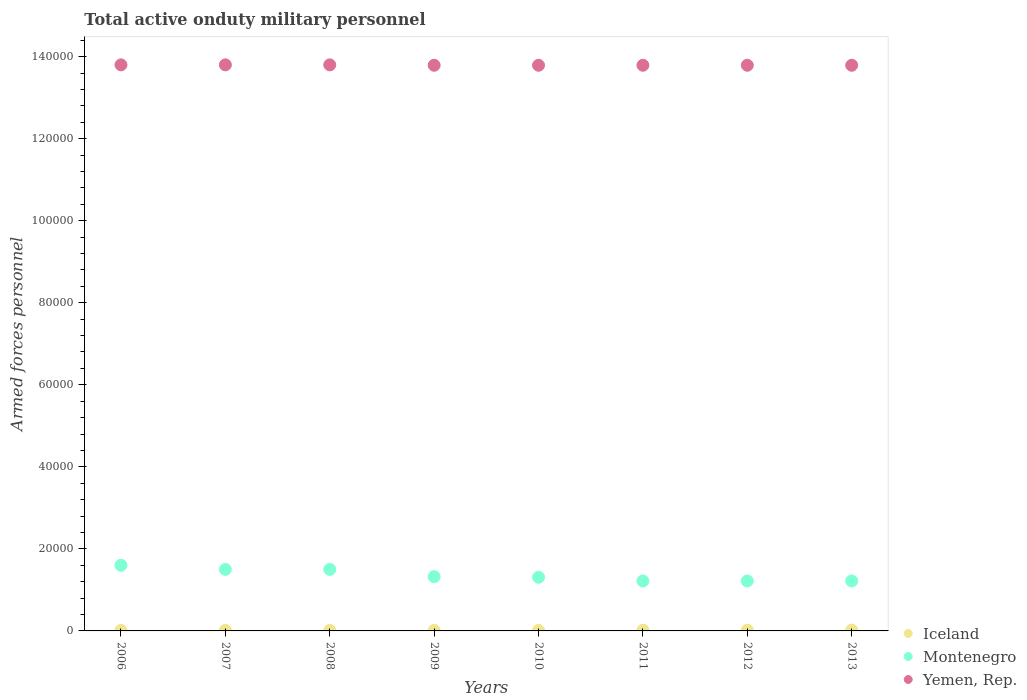Is the number of dotlines equal to the number of legend labels?
Ensure brevity in your answer.  Yes. What is the number of armed forces personnel in Iceland in 2008?
Keep it short and to the point. 130. Across all years, what is the maximum number of armed forces personnel in Montenegro?
Your answer should be very brief. 1.60e+04. Across all years, what is the minimum number of armed forces personnel in Iceland?
Provide a succinct answer. 130. In which year was the number of armed forces personnel in Iceland minimum?
Provide a short and direct response. 2006. What is the total number of armed forces personnel in Iceland in the graph?
Offer a very short reply. 1210. What is the difference between the number of armed forces personnel in Iceland in 2006 and that in 2010?
Provide a short and direct response. 0. What is the difference between the number of armed forces personnel in Yemen, Rep. in 2013 and the number of armed forces personnel in Iceland in 2009?
Provide a short and direct response. 1.38e+05. What is the average number of armed forces personnel in Montenegro per year?
Your answer should be very brief. 1.36e+04. In the year 2011, what is the difference between the number of armed forces personnel in Iceland and number of armed forces personnel in Yemen, Rep.?
Your response must be concise. -1.38e+05. What is the ratio of the number of armed forces personnel in Iceland in 2008 to that in 2011?
Ensure brevity in your answer.  0.72. Is the number of armed forces personnel in Yemen, Rep. in 2007 less than that in 2011?
Keep it short and to the point. No. What is the difference between the highest and the lowest number of armed forces personnel in Iceland?
Make the answer very short. 70. In how many years, is the number of armed forces personnel in Iceland greater than the average number of armed forces personnel in Iceland taken over all years?
Offer a terse response. 3. Does the number of armed forces personnel in Montenegro monotonically increase over the years?
Your answer should be compact. No. Is the number of armed forces personnel in Iceland strictly greater than the number of armed forces personnel in Montenegro over the years?
Make the answer very short. No. How many dotlines are there?
Keep it short and to the point. 3. How many years are there in the graph?
Give a very brief answer. 8. Does the graph contain grids?
Your answer should be compact. No. Where does the legend appear in the graph?
Offer a terse response. Bottom right. How many legend labels are there?
Provide a succinct answer. 3. What is the title of the graph?
Your answer should be compact. Total active onduty military personnel. Does "Russian Federation" appear as one of the legend labels in the graph?
Give a very brief answer. No. What is the label or title of the Y-axis?
Provide a short and direct response. Armed forces personnel. What is the Armed forces personnel of Iceland in 2006?
Offer a terse response. 130. What is the Armed forces personnel of Montenegro in 2006?
Ensure brevity in your answer.  1.60e+04. What is the Armed forces personnel in Yemen, Rep. in 2006?
Provide a short and direct response. 1.38e+05. What is the Armed forces personnel in Iceland in 2007?
Your answer should be compact. 130. What is the Armed forces personnel of Montenegro in 2007?
Your response must be concise. 1.50e+04. What is the Armed forces personnel in Yemen, Rep. in 2007?
Offer a terse response. 1.38e+05. What is the Armed forces personnel of Iceland in 2008?
Your answer should be compact. 130. What is the Armed forces personnel of Montenegro in 2008?
Ensure brevity in your answer.  1.50e+04. What is the Armed forces personnel in Yemen, Rep. in 2008?
Your answer should be very brief. 1.38e+05. What is the Armed forces personnel of Iceland in 2009?
Provide a short and direct response. 130. What is the Armed forces personnel in Montenegro in 2009?
Give a very brief answer. 1.32e+04. What is the Armed forces personnel in Yemen, Rep. in 2009?
Offer a very short reply. 1.38e+05. What is the Armed forces personnel of Iceland in 2010?
Provide a short and direct response. 130. What is the Armed forces personnel of Montenegro in 2010?
Offer a terse response. 1.31e+04. What is the Armed forces personnel of Yemen, Rep. in 2010?
Keep it short and to the point. 1.38e+05. What is the Armed forces personnel in Iceland in 2011?
Your answer should be compact. 180. What is the Armed forces personnel of Montenegro in 2011?
Offer a very short reply. 1.22e+04. What is the Armed forces personnel in Yemen, Rep. in 2011?
Your answer should be very brief. 1.38e+05. What is the Armed forces personnel of Iceland in 2012?
Ensure brevity in your answer.  180. What is the Armed forces personnel in Montenegro in 2012?
Your answer should be compact. 1.22e+04. What is the Armed forces personnel of Yemen, Rep. in 2012?
Provide a succinct answer. 1.38e+05. What is the Armed forces personnel in Montenegro in 2013?
Your answer should be very brief. 1.22e+04. What is the Armed forces personnel of Yemen, Rep. in 2013?
Offer a terse response. 1.38e+05. Across all years, what is the maximum Armed forces personnel of Montenegro?
Provide a succinct answer. 1.60e+04. Across all years, what is the maximum Armed forces personnel of Yemen, Rep.?
Ensure brevity in your answer.  1.38e+05. Across all years, what is the minimum Armed forces personnel in Iceland?
Your response must be concise. 130. Across all years, what is the minimum Armed forces personnel in Montenegro?
Offer a very short reply. 1.22e+04. Across all years, what is the minimum Armed forces personnel of Yemen, Rep.?
Provide a succinct answer. 1.38e+05. What is the total Armed forces personnel in Iceland in the graph?
Your answer should be very brief. 1210. What is the total Armed forces personnel of Montenegro in the graph?
Provide a succinct answer. 1.09e+05. What is the total Armed forces personnel of Yemen, Rep. in the graph?
Give a very brief answer. 1.10e+06. What is the difference between the Armed forces personnel of Iceland in 2006 and that in 2007?
Offer a terse response. 0. What is the difference between the Armed forces personnel of Iceland in 2006 and that in 2008?
Provide a short and direct response. 0. What is the difference between the Armed forces personnel in Montenegro in 2006 and that in 2008?
Offer a very short reply. 1000. What is the difference between the Armed forces personnel in Montenegro in 2006 and that in 2009?
Provide a short and direct response. 2773. What is the difference between the Armed forces personnel in Montenegro in 2006 and that in 2010?
Keep it short and to the point. 2916. What is the difference between the Armed forces personnel in Yemen, Rep. in 2006 and that in 2010?
Your answer should be compact. 100. What is the difference between the Armed forces personnel of Iceland in 2006 and that in 2011?
Provide a short and direct response. -50. What is the difference between the Armed forces personnel in Montenegro in 2006 and that in 2011?
Make the answer very short. 3820. What is the difference between the Armed forces personnel of Montenegro in 2006 and that in 2012?
Offer a very short reply. 3820. What is the difference between the Armed forces personnel in Iceland in 2006 and that in 2013?
Your answer should be very brief. -70. What is the difference between the Armed forces personnel of Montenegro in 2006 and that in 2013?
Your answer should be very brief. 3820. What is the difference between the Armed forces personnel of Iceland in 2007 and that in 2008?
Offer a very short reply. 0. What is the difference between the Armed forces personnel in Yemen, Rep. in 2007 and that in 2008?
Your answer should be compact. 0. What is the difference between the Armed forces personnel of Montenegro in 2007 and that in 2009?
Keep it short and to the point. 1773. What is the difference between the Armed forces personnel of Yemen, Rep. in 2007 and that in 2009?
Provide a short and direct response. 100. What is the difference between the Armed forces personnel of Montenegro in 2007 and that in 2010?
Offer a very short reply. 1916. What is the difference between the Armed forces personnel in Montenegro in 2007 and that in 2011?
Provide a succinct answer. 2820. What is the difference between the Armed forces personnel of Montenegro in 2007 and that in 2012?
Your answer should be compact. 2820. What is the difference between the Armed forces personnel of Iceland in 2007 and that in 2013?
Your response must be concise. -70. What is the difference between the Armed forces personnel in Montenegro in 2007 and that in 2013?
Ensure brevity in your answer.  2820. What is the difference between the Armed forces personnel of Iceland in 2008 and that in 2009?
Provide a short and direct response. 0. What is the difference between the Armed forces personnel of Montenegro in 2008 and that in 2009?
Offer a terse response. 1773. What is the difference between the Armed forces personnel in Iceland in 2008 and that in 2010?
Your response must be concise. 0. What is the difference between the Armed forces personnel in Montenegro in 2008 and that in 2010?
Your answer should be compact. 1916. What is the difference between the Armed forces personnel in Montenegro in 2008 and that in 2011?
Provide a short and direct response. 2820. What is the difference between the Armed forces personnel in Yemen, Rep. in 2008 and that in 2011?
Your response must be concise. 100. What is the difference between the Armed forces personnel of Montenegro in 2008 and that in 2012?
Offer a terse response. 2820. What is the difference between the Armed forces personnel of Yemen, Rep. in 2008 and that in 2012?
Your answer should be very brief. 100. What is the difference between the Armed forces personnel in Iceland in 2008 and that in 2013?
Provide a short and direct response. -70. What is the difference between the Armed forces personnel of Montenegro in 2008 and that in 2013?
Give a very brief answer. 2820. What is the difference between the Armed forces personnel in Yemen, Rep. in 2008 and that in 2013?
Ensure brevity in your answer.  100. What is the difference between the Armed forces personnel of Iceland in 2009 and that in 2010?
Make the answer very short. 0. What is the difference between the Armed forces personnel of Montenegro in 2009 and that in 2010?
Give a very brief answer. 143. What is the difference between the Armed forces personnel in Montenegro in 2009 and that in 2011?
Provide a succinct answer. 1047. What is the difference between the Armed forces personnel in Yemen, Rep. in 2009 and that in 2011?
Give a very brief answer. 0. What is the difference between the Armed forces personnel in Montenegro in 2009 and that in 2012?
Your answer should be compact. 1047. What is the difference between the Armed forces personnel in Yemen, Rep. in 2009 and that in 2012?
Make the answer very short. 0. What is the difference between the Armed forces personnel in Iceland in 2009 and that in 2013?
Your answer should be compact. -70. What is the difference between the Armed forces personnel of Montenegro in 2009 and that in 2013?
Ensure brevity in your answer.  1047. What is the difference between the Armed forces personnel of Montenegro in 2010 and that in 2011?
Your response must be concise. 904. What is the difference between the Armed forces personnel in Iceland in 2010 and that in 2012?
Keep it short and to the point. -50. What is the difference between the Armed forces personnel of Montenegro in 2010 and that in 2012?
Make the answer very short. 904. What is the difference between the Armed forces personnel of Iceland in 2010 and that in 2013?
Offer a very short reply. -70. What is the difference between the Armed forces personnel of Montenegro in 2010 and that in 2013?
Provide a short and direct response. 904. What is the difference between the Armed forces personnel in Yemen, Rep. in 2010 and that in 2013?
Provide a short and direct response. 0. What is the difference between the Armed forces personnel in Iceland in 2011 and that in 2012?
Offer a terse response. 0. What is the difference between the Armed forces personnel of Yemen, Rep. in 2011 and that in 2012?
Ensure brevity in your answer.  0. What is the difference between the Armed forces personnel of Iceland in 2012 and that in 2013?
Your answer should be compact. -20. What is the difference between the Armed forces personnel in Montenegro in 2012 and that in 2013?
Your response must be concise. 0. What is the difference between the Armed forces personnel in Iceland in 2006 and the Armed forces personnel in Montenegro in 2007?
Provide a short and direct response. -1.49e+04. What is the difference between the Armed forces personnel of Iceland in 2006 and the Armed forces personnel of Yemen, Rep. in 2007?
Your answer should be compact. -1.38e+05. What is the difference between the Armed forces personnel of Montenegro in 2006 and the Armed forces personnel of Yemen, Rep. in 2007?
Offer a terse response. -1.22e+05. What is the difference between the Armed forces personnel of Iceland in 2006 and the Armed forces personnel of Montenegro in 2008?
Make the answer very short. -1.49e+04. What is the difference between the Armed forces personnel of Iceland in 2006 and the Armed forces personnel of Yemen, Rep. in 2008?
Your response must be concise. -1.38e+05. What is the difference between the Armed forces personnel in Montenegro in 2006 and the Armed forces personnel in Yemen, Rep. in 2008?
Make the answer very short. -1.22e+05. What is the difference between the Armed forces personnel in Iceland in 2006 and the Armed forces personnel in Montenegro in 2009?
Ensure brevity in your answer.  -1.31e+04. What is the difference between the Armed forces personnel in Iceland in 2006 and the Armed forces personnel in Yemen, Rep. in 2009?
Keep it short and to the point. -1.38e+05. What is the difference between the Armed forces personnel in Montenegro in 2006 and the Armed forces personnel in Yemen, Rep. in 2009?
Your response must be concise. -1.22e+05. What is the difference between the Armed forces personnel in Iceland in 2006 and the Armed forces personnel in Montenegro in 2010?
Offer a terse response. -1.30e+04. What is the difference between the Armed forces personnel in Iceland in 2006 and the Armed forces personnel in Yemen, Rep. in 2010?
Offer a terse response. -1.38e+05. What is the difference between the Armed forces personnel of Montenegro in 2006 and the Armed forces personnel of Yemen, Rep. in 2010?
Give a very brief answer. -1.22e+05. What is the difference between the Armed forces personnel in Iceland in 2006 and the Armed forces personnel in Montenegro in 2011?
Ensure brevity in your answer.  -1.20e+04. What is the difference between the Armed forces personnel in Iceland in 2006 and the Armed forces personnel in Yemen, Rep. in 2011?
Offer a very short reply. -1.38e+05. What is the difference between the Armed forces personnel of Montenegro in 2006 and the Armed forces personnel of Yemen, Rep. in 2011?
Offer a very short reply. -1.22e+05. What is the difference between the Armed forces personnel of Iceland in 2006 and the Armed forces personnel of Montenegro in 2012?
Make the answer very short. -1.20e+04. What is the difference between the Armed forces personnel in Iceland in 2006 and the Armed forces personnel in Yemen, Rep. in 2012?
Provide a short and direct response. -1.38e+05. What is the difference between the Armed forces personnel of Montenegro in 2006 and the Armed forces personnel of Yemen, Rep. in 2012?
Offer a terse response. -1.22e+05. What is the difference between the Armed forces personnel of Iceland in 2006 and the Armed forces personnel of Montenegro in 2013?
Keep it short and to the point. -1.20e+04. What is the difference between the Armed forces personnel in Iceland in 2006 and the Armed forces personnel in Yemen, Rep. in 2013?
Keep it short and to the point. -1.38e+05. What is the difference between the Armed forces personnel of Montenegro in 2006 and the Armed forces personnel of Yemen, Rep. in 2013?
Provide a succinct answer. -1.22e+05. What is the difference between the Armed forces personnel in Iceland in 2007 and the Armed forces personnel in Montenegro in 2008?
Make the answer very short. -1.49e+04. What is the difference between the Armed forces personnel of Iceland in 2007 and the Armed forces personnel of Yemen, Rep. in 2008?
Your answer should be very brief. -1.38e+05. What is the difference between the Armed forces personnel of Montenegro in 2007 and the Armed forces personnel of Yemen, Rep. in 2008?
Offer a terse response. -1.23e+05. What is the difference between the Armed forces personnel of Iceland in 2007 and the Armed forces personnel of Montenegro in 2009?
Make the answer very short. -1.31e+04. What is the difference between the Armed forces personnel of Iceland in 2007 and the Armed forces personnel of Yemen, Rep. in 2009?
Provide a short and direct response. -1.38e+05. What is the difference between the Armed forces personnel of Montenegro in 2007 and the Armed forces personnel of Yemen, Rep. in 2009?
Provide a short and direct response. -1.23e+05. What is the difference between the Armed forces personnel of Iceland in 2007 and the Armed forces personnel of Montenegro in 2010?
Your answer should be compact. -1.30e+04. What is the difference between the Armed forces personnel in Iceland in 2007 and the Armed forces personnel in Yemen, Rep. in 2010?
Provide a short and direct response. -1.38e+05. What is the difference between the Armed forces personnel of Montenegro in 2007 and the Armed forces personnel of Yemen, Rep. in 2010?
Offer a terse response. -1.23e+05. What is the difference between the Armed forces personnel in Iceland in 2007 and the Armed forces personnel in Montenegro in 2011?
Your answer should be compact. -1.20e+04. What is the difference between the Armed forces personnel in Iceland in 2007 and the Armed forces personnel in Yemen, Rep. in 2011?
Offer a very short reply. -1.38e+05. What is the difference between the Armed forces personnel of Montenegro in 2007 and the Armed forces personnel of Yemen, Rep. in 2011?
Offer a terse response. -1.23e+05. What is the difference between the Armed forces personnel of Iceland in 2007 and the Armed forces personnel of Montenegro in 2012?
Provide a short and direct response. -1.20e+04. What is the difference between the Armed forces personnel of Iceland in 2007 and the Armed forces personnel of Yemen, Rep. in 2012?
Your answer should be compact. -1.38e+05. What is the difference between the Armed forces personnel in Montenegro in 2007 and the Armed forces personnel in Yemen, Rep. in 2012?
Make the answer very short. -1.23e+05. What is the difference between the Armed forces personnel in Iceland in 2007 and the Armed forces personnel in Montenegro in 2013?
Ensure brevity in your answer.  -1.20e+04. What is the difference between the Armed forces personnel of Iceland in 2007 and the Armed forces personnel of Yemen, Rep. in 2013?
Ensure brevity in your answer.  -1.38e+05. What is the difference between the Armed forces personnel of Montenegro in 2007 and the Armed forces personnel of Yemen, Rep. in 2013?
Keep it short and to the point. -1.23e+05. What is the difference between the Armed forces personnel of Iceland in 2008 and the Armed forces personnel of Montenegro in 2009?
Give a very brief answer. -1.31e+04. What is the difference between the Armed forces personnel of Iceland in 2008 and the Armed forces personnel of Yemen, Rep. in 2009?
Provide a short and direct response. -1.38e+05. What is the difference between the Armed forces personnel of Montenegro in 2008 and the Armed forces personnel of Yemen, Rep. in 2009?
Make the answer very short. -1.23e+05. What is the difference between the Armed forces personnel of Iceland in 2008 and the Armed forces personnel of Montenegro in 2010?
Your response must be concise. -1.30e+04. What is the difference between the Armed forces personnel of Iceland in 2008 and the Armed forces personnel of Yemen, Rep. in 2010?
Keep it short and to the point. -1.38e+05. What is the difference between the Armed forces personnel of Montenegro in 2008 and the Armed forces personnel of Yemen, Rep. in 2010?
Provide a short and direct response. -1.23e+05. What is the difference between the Armed forces personnel in Iceland in 2008 and the Armed forces personnel in Montenegro in 2011?
Your answer should be very brief. -1.20e+04. What is the difference between the Armed forces personnel in Iceland in 2008 and the Armed forces personnel in Yemen, Rep. in 2011?
Provide a short and direct response. -1.38e+05. What is the difference between the Armed forces personnel in Montenegro in 2008 and the Armed forces personnel in Yemen, Rep. in 2011?
Provide a short and direct response. -1.23e+05. What is the difference between the Armed forces personnel in Iceland in 2008 and the Armed forces personnel in Montenegro in 2012?
Give a very brief answer. -1.20e+04. What is the difference between the Armed forces personnel in Iceland in 2008 and the Armed forces personnel in Yemen, Rep. in 2012?
Give a very brief answer. -1.38e+05. What is the difference between the Armed forces personnel in Montenegro in 2008 and the Armed forces personnel in Yemen, Rep. in 2012?
Provide a short and direct response. -1.23e+05. What is the difference between the Armed forces personnel in Iceland in 2008 and the Armed forces personnel in Montenegro in 2013?
Your answer should be compact. -1.20e+04. What is the difference between the Armed forces personnel of Iceland in 2008 and the Armed forces personnel of Yemen, Rep. in 2013?
Your answer should be very brief. -1.38e+05. What is the difference between the Armed forces personnel of Montenegro in 2008 and the Armed forces personnel of Yemen, Rep. in 2013?
Keep it short and to the point. -1.23e+05. What is the difference between the Armed forces personnel of Iceland in 2009 and the Armed forces personnel of Montenegro in 2010?
Provide a short and direct response. -1.30e+04. What is the difference between the Armed forces personnel in Iceland in 2009 and the Armed forces personnel in Yemen, Rep. in 2010?
Your response must be concise. -1.38e+05. What is the difference between the Armed forces personnel in Montenegro in 2009 and the Armed forces personnel in Yemen, Rep. in 2010?
Your response must be concise. -1.25e+05. What is the difference between the Armed forces personnel of Iceland in 2009 and the Armed forces personnel of Montenegro in 2011?
Your answer should be very brief. -1.20e+04. What is the difference between the Armed forces personnel of Iceland in 2009 and the Armed forces personnel of Yemen, Rep. in 2011?
Keep it short and to the point. -1.38e+05. What is the difference between the Armed forces personnel of Montenegro in 2009 and the Armed forces personnel of Yemen, Rep. in 2011?
Your response must be concise. -1.25e+05. What is the difference between the Armed forces personnel of Iceland in 2009 and the Armed forces personnel of Montenegro in 2012?
Provide a short and direct response. -1.20e+04. What is the difference between the Armed forces personnel of Iceland in 2009 and the Armed forces personnel of Yemen, Rep. in 2012?
Offer a terse response. -1.38e+05. What is the difference between the Armed forces personnel of Montenegro in 2009 and the Armed forces personnel of Yemen, Rep. in 2012?
Ensure brevity in your answer.  -1.25e+05. What is the difference between the Armed forces personnel of Iceland in 2009 and the Armed forces personnel of Montenegro in 2013?
Offer a terse response. -1.20e+04. What is the difference between the Armed forces personnel in Iceland in 2009 and the Armed forces personnel in Yemen, Rep. in 2013?
Offer a terse response. -1.38e+05. What is the difference between the Armed forces personnel of Montenegro in 2009 and the Armed forces personnel of Yemen, Rep. in 2013?
Your answer should be compact. -1.25e+05. What is the difference between the Armed forces personnel of Iceland in 2010 and the Armed forces personnel of Montenegro in 2011?
Ensure brevity in your answer.  -1.20e+04. What is the difference between the Armed forces personnel in Iceland in 2010 and the Armed forces personnel in Yemen, Rep. in 2011?
Your answer should be compact. -1.38e+05. What is the difference between the Armed forces personnel of Montenegro in 2010 and the Armed forces personnel of Yemen, Rep. in 2011?
Offer a terse response. -1.25e+05. What is the difference between the Armed forces personnel of Iceland in 2010 and the Armed forces personnel of Montenegro in 2012?
Give a very brief answer. -1.20e+04. What is the difference between the Armed forces personnel of Iceland in 2010 and the Armed forces personnel of Yemen, Rep. in 2012?
Provide a short and direct response. -1.38e+05. What is the difference between the Armed forces personnel of Montenegro in 2010 and the Armed forces personnel of Yemen, Rep. in 2012?
Provide a succinct answer. -1.25e+05. What is the difference between the Armed forces personnel of Iceland in 2010 and the Armed forces personnel of Montenegro in 2013?
Provide a short and direct response. -1.20e+04. What is the difference between the Armed forces personnel of Iceland in 2010 and the Armed forces personnel of Yemen, Rep. in 2013?
Provide a short and direct response. -1.38e+05. What is the difference between the Armed forces personnel in Montenegro in 2010 and the Armed forces personnel in Yemen, Rep. in 2013?
Your answer should be compact. -1.25e+05. What is the difference between the Armed forces personnel in Iceland in 2011 and the Armed forces personnel in Montenegro in 2012?
Offer a very short reply. -1.20e+04. What is the difference between the Armed forces personnel in Iceland in 2011 and the Armed forces personnel in Yemen, Rep. in 2012?
Your response must be concise. -1.38e+05. What is the difference between the Armed forces personnel in Montenegro in 2011 and the Armed forces personnel in Yemen, Rep. in 2012?
Provide a short and direct response. -1.26e+05. What is the difference between the Armed forces personnel in Iceland in 2011 and the Armed forces personnel in Montenegro in 2013?
Keep it short and to the point. -1.20e+04. What is the difference between the Armed forces personnel of Iceland in 2011 and the Armed forces personnel of Yemen, Rep. in 2013?
Provide a succinct answer. -1.38e+05. What is the difference between the Armed forces personnel of Montenegro in 2011 and the Armed forces personnel of Yemen, Rep. in 2013?
Give a very brief answer. -1.26e+05. What is the difference between the Armed forces personnel of Iceland in 2012 and the Armed forces personnel of Montenegro in 2013?
Your answer should be very brief. -1.20e+04. What is the difference between the Armed forces personnel in Iceland in 2012 and the Armed forces personnel in Yemen, Rep. in 2013?
Ensure brevity in your answer.  -1.38e+05. What is the difference between the Armed forces personnel of Montenegro in 2012 and the Armed forces personnel of Yemen, Rep. in 2013?
Offer a terse response. -1.26e+05. What is the average Armed forces personnel in Iceland per year?
Your answer should be compact. 151.25. What is the average Armed forces personnel of Montenegro per year?
Your answer should be compact. 1.36e+04. What is the average Armed forces personnel of Yemen, Rep. per year?
Your response must be concise. 1.38e+05. In the year 2006, what is the difference between the Armed forces personnel of Iceland and Armed forces personnel of Montenegro?
Your response must be concise. -1.59e+04. In the year 2006, what is the difference between the Armed forces personnel in Iceland and Armed forces personnel in Yemen, Rep.?
Your response must be concise. -1.38e+05. In the year 2006, what is the difference between the Armed forces personnel of Montenegro and Armed forces personnel of Yemen, Rep.?
Give a very brief answer. -1.22e+05. In the year 2007, what is the difference between the Armed forces personnel in Iceland and Armed forces personnel in Montenegro?
Offer a terse response. -1.49e+04. In the year 2007, what is the difference between the Armed forces personnel of Iceland and Armed forces personnel of Yemen, Rep.?
Offer a terse response. -1.38e+05. In the year 2007, what is the difference between the Armed forces personnel in Montenegro and Armed forces personnel in Yemen, Rep.?
Give a very brief answer. -1.23e+05. In the year 2008, what is the difference between the Armed forces personnel of Iceland and Armed forces personnel of Montenegro?
Provide a succinct answer. -1.49e+04. In the year 2008, what is the difference between the Armed forces personnel of Iceland and Armed forces personnel of Yemen, Rep.?
Ensure brevity in your answer.  -1.38e+05. In the year 2008, what is the difference between the Armed forces personnel of Montenegro and Armed forces personnel of Yemen, Rep.?
Your response must be concise. -1.23e+05. In the year 2009, what is the difference between the Armed forces personnel of Iceland and Armed forces personnel of Montenegro?
Your answer should be compact. -1.31e+04. In the year 2009, what is the difference between the Armed forces personnel of Iceland and Armed forces personnel of Yemen, Rep.?
Keep it short and to the point. -1.38e+05. In the year 2009, what is the difference between the Armed forces personnel in Montenegro and Armed forces personnel in Yemen, Rep.?
Your answer should be very brief. -1.25e+05. In the year 2010, what is the difference between the Armed forces personnel of Iceland and Armed forces personnel of Montenegro?
Ensure brevity in your answer.  -1.30e+04. In the year 2010, what is the difference between the Armed forces personnel in Iceland and Armed forces personnel in Yemen, Rep.?
Offer a terse response. -1.38e+05. In the year 2010, what is the difference between the Armed forces personnel of Montenegro and Armed forces personnel of Yemen, Rep.?
Offer a very short reply. -1.25e+05. In the year 2011, what is the difference between the Armed forces personnel in Iceland and Armed forces personnel in Montenegro?
Your response must be concise. -1.20e+04. In the year 2011, what is the difference between the Armed forces personnel in Iceland and Armed forces personnel in Yemen, Rep.?
Give a very brief answer. -1.38e+05. In the year 2011, what is the difference between the Armed forces personnel in Montenegro and Armed forces personnel in Yemen, Rep.?
Your answer should be very brief. -1.26e+05. In the year 2012, what is the difference between the Armed forces personnel in Iceland and Armed forces personnel in Montenegro?
Provide a short and direct response. -1.20e+04. In the year 2012, what is the difference between the Armed forces personnel of Iceland and Armed forces personnel of Yemen, Rep.?
Make the answer very short. -1.38e+05. In the year 2012, what is the difference between the Armed forces personnel in Montenegro and Armed forces personnel in Yemen, Rep.?
Ensure brevity in your answer.  -1.26e+05. In the year 2013, what is the difference between the Armed forces personnel in Iceland and Armed forces personnel in Montenegro?
Give a very brief answer. -1.20e+04. In the year 2013, what is the difference between the Armed forces personnel of Iceland and Armed forces personnel of Yemen, Rep.?
Offer a very short reply. -1.38e+05. In the year 2013, what is the difference between the Armed forces personnel in Montenegro and Armed forces personnel in Yemen, Rep.?
Your answer should be very brief. -1.26e+05. What is the ratio of the Armed forces personnel in Iceland in 2006 to that in 2007?
Offer a terse response. 1. What is the ratio of the Armed forces personnel in Montenegro in 2006 to that in 2007?
Ensure brevity in your answer.  1.07. What is the ratio of the Armed forces personnel in Yemen, Rep. in 2006 to that in 2007?
Ensure brevity in your answer.  1. What is the ratio of the Armed forces personnel of Iceland in 2006 to that in 2008?
Your response must be concise. 1. What is the ratio of the Armed forces personnel in Montenegro in 2006 to that in 2008?
Make the answer very short. 1.07. What is the ratio of the Armed forces personnel of Yemen, Rep. in 2006 to that in 2008?
Make the answer very short. 1. What is the ratio of the Armed forces personnel of Montenegro in 2006 to that in 2009?
Your answer should be compact. 1.21. What is the ratio of the Armed forces personnel of Yemen, Rep. in 2006 to that in 2009?
Your answer should be very brief. 1. What is the ratio of the Armed forces personnel in Montenegro in 2006 to that in 2010?
Give a very brief answer. 1.22. What is the ratio of the Armed forces personnel in Iceland in 2006 to that in 2011?
Keep it short and to the point. 0.72. What is the ratio of the Armed forces personnel of Montenegro in 2006 to that in 2011?
Your response must be concise. 1.31. What is the ratio of the Armed forces personnel of Iceland in 2006 to that in 2012?
Your answer should be compact. 0.72. What is the ratio of the Armed forces personnel in Montenegro in 2006 to that in 2012?
Your answer should be very brief. 1.31. What is the ratio of the Armed forces personnel in Yemen, Rep. in 2006 to that in 2012?
Your response must be concise. 1. What is the ratio of the Armed forces personnel in Iceland in 2006 to that in 2013?
Provide a short and direct response. 0.65. What is the ratio of the Armed forces personnel in Montenegro in 2006 to that in 2013?
Make the answer very short. 1.31. What is the ratio of the Armed forces personnel of Yemen, Rep. in 2006 to that in 2013?
Offer a very short reply. 1. What is the ratio of the Armed forces personnel of Montenegro in 2007 to that in 2009?
Keep it short and to the point. 1.13. What is the ratio of the Armed forces personnel in Yemen, Rep. in 2007 to that in 2009?
Keep it short and to the point. 1. What is the ratio of the Armed forces personnel of Iceland in 2007 to that in 2010?
Make the answer very short. 1. What is the ratio of the Armed forces personnel of Montenegro in 2007 to that in 2010?
Make the answer very short. 1.15. What is the ratio of the Armed forces personnel in Iceland in 2007 to that in 2011?
Provide a short and direct response. 0.72. What is the ratio of the Armed forces personnel in Montenegro in 2007 to that in 2011?
Give a very brief answer. 1.23. What is the ratio of the Armed forces personnel in Iceland in 2007 to that in 2012?
Your answer should be very brief. 0.72. What is the ratio of the Armed forces personnel in Montenegro in 2007 to that in 2012?
Keep it short and to the point. 1.23. What is the ratio of the Armed forces personnel of Yemen, Rep. in 2007 to that in 2012?
Provide a succinct answer. 1. What is the ratio of the Armed forces personnel of Iceland in 2007 to that in 2013?
Offer a very short reply. 0.65. What is the ratio of the Armed forces personnel in Montenegro in 2007 to that in 2013?
Offer a terse response. 1.23. What is the ratio of the Armed forces personnel of Montenegro in 2008 to that in 2009?
Make the answer very short. 1.13. What is the ratio of the Armed forces personnel in Yemen, Rep. in 2008 to that in 2009?
Give a very brief answer. 1. What is the ratio of the Armed forces personnel of Montenegro in 2008 to that in 2010?
Your answer should be very brief. 1.15. What is the ratio of the Armed forces personnel in Iceland in 2008 to that in 2011?
Provide a succinct answer. 0.72. What is the ratio of the Armed forces personnel in Montenegro in 2008 to that in 2011?
Ensure brevity in your answer.  1.23. What is the ratio of the Armed forces personnel in Yemen, Rep. in 2008 to that in 2011?
Offer a terse response. 1. What is the ratio of the Armed forces personnel of Iceland in 2008 to that in 2012?
Give a very brief answer. 0.72. What is the ratio of the Armed forces personnel in Montenegro in 2008 to that in 2012?
Keep it short and to the point. 1.23. What is the ratio of the Armed forces personnel in Iceland in 2008 to that in 2013?
Your answer should be very brief. 0.65. What is the ratio of the Armed forces personnel of Montenegro in 2008 to that in 2013?
Make the answer very short. 1.23. What is the ratio of the Armed forces personnel in Montenegro in 2009 to that in 2010?
Give a very brief answer. 1.01. What is the ratio of the Armed forces personnel in Iceland in 2009 to that in 2011?
Give a very brief answer. 0.72. What is the ratio of the Armed forces personnel of Montenegro in 2009 to that in 2011?
Your answer should be compact. 1.09. What is the ratio of the Armed forces personnel in Yemen, Rep. in 2009 to that in 2011?
Provide a short and direct response. 1. What is the ratio of the Armed forces personnel of Iceland in 2009 to that in 2012?
Provide a succinct answer. 0.72. What is the ratio of the Armed forces personnel of Montenegro in 2009 to that in 2012?
Provide a short and direct response. 1.09. What is the ratio of the Armed forces personnel of Yemen, Rep. in 2009 to that in 2012?
Give a very brief answer. 1. What is the ratio of the Armed forces personnel in Iceland in 2009 to that in 2013?
Your response must be concise. 0.65. What is the ratio of the Armed forces personnel in Montenegro in 2009 to that in 2013?
Offer a very short reply. 1.09. What is the ratio of the Armed forces personnel in Iceland in 2010 to that in 2011?
Offer a terse response. 0.72. What is the ratio of the Armed forces personnel in Montenegro in 2010 to that in 2011?
Offer a very short reply. 1.07. What is the ratio of the Armed forces personnel of Iceland in 2010 to that in 2012?
Make the answer very short. 0.72. What is the ratio of the Armed forces personnel of Montenegro in 2010 to that in 2012?
Your response must be concise. 1.07. What is the ratio of the Armed forces personnel of Yemen, Rep. in 2010 to that in 2012?
Give a very brief answer. 1. What is the ratio of the Armed forces personnel in Iceland in 2010 to that in 2013?
Offer a very short reply. 0.65. What is the ratio of the Armed forces personnel in Montenegro in 2010 to that in 2013?
Provide a short and direct response. 1.07. What is the ratio of the Armed forces personnel in Yemen, Rep. in 2010 to that in 2013?
Make the answer very short. 1. What is the ratio of the Armed forces personnel in Iceland in 2011 to that in 2012?
Your answer should be very brief. 1. What is the ratio of the Armed forces personnel in Montenegro in 2011 to that in 2012?
Offer a very short reply. 1. What is the ratio of the Armed forces personnel of Yemen, Rep. in 2011 to that in 2012?
Provide a short and direct response. 1. What is the ratio of the Armed forces personnel in Montenegro in 2011 to that in 2013?
Your answer should be compact. 1. What is the ratio of the Armed forces personnel of Iceland in 2012 to that in 2013?
Your answer should be very brief. 0.9. What is the difference between the highest and the second highest Armed forces personnel of Iceland?
Your response must be concise. 20. What is the difference between the highest and the lowest Armed forces personnel of Montenegro?
Keep it short and to the point. 3820. 